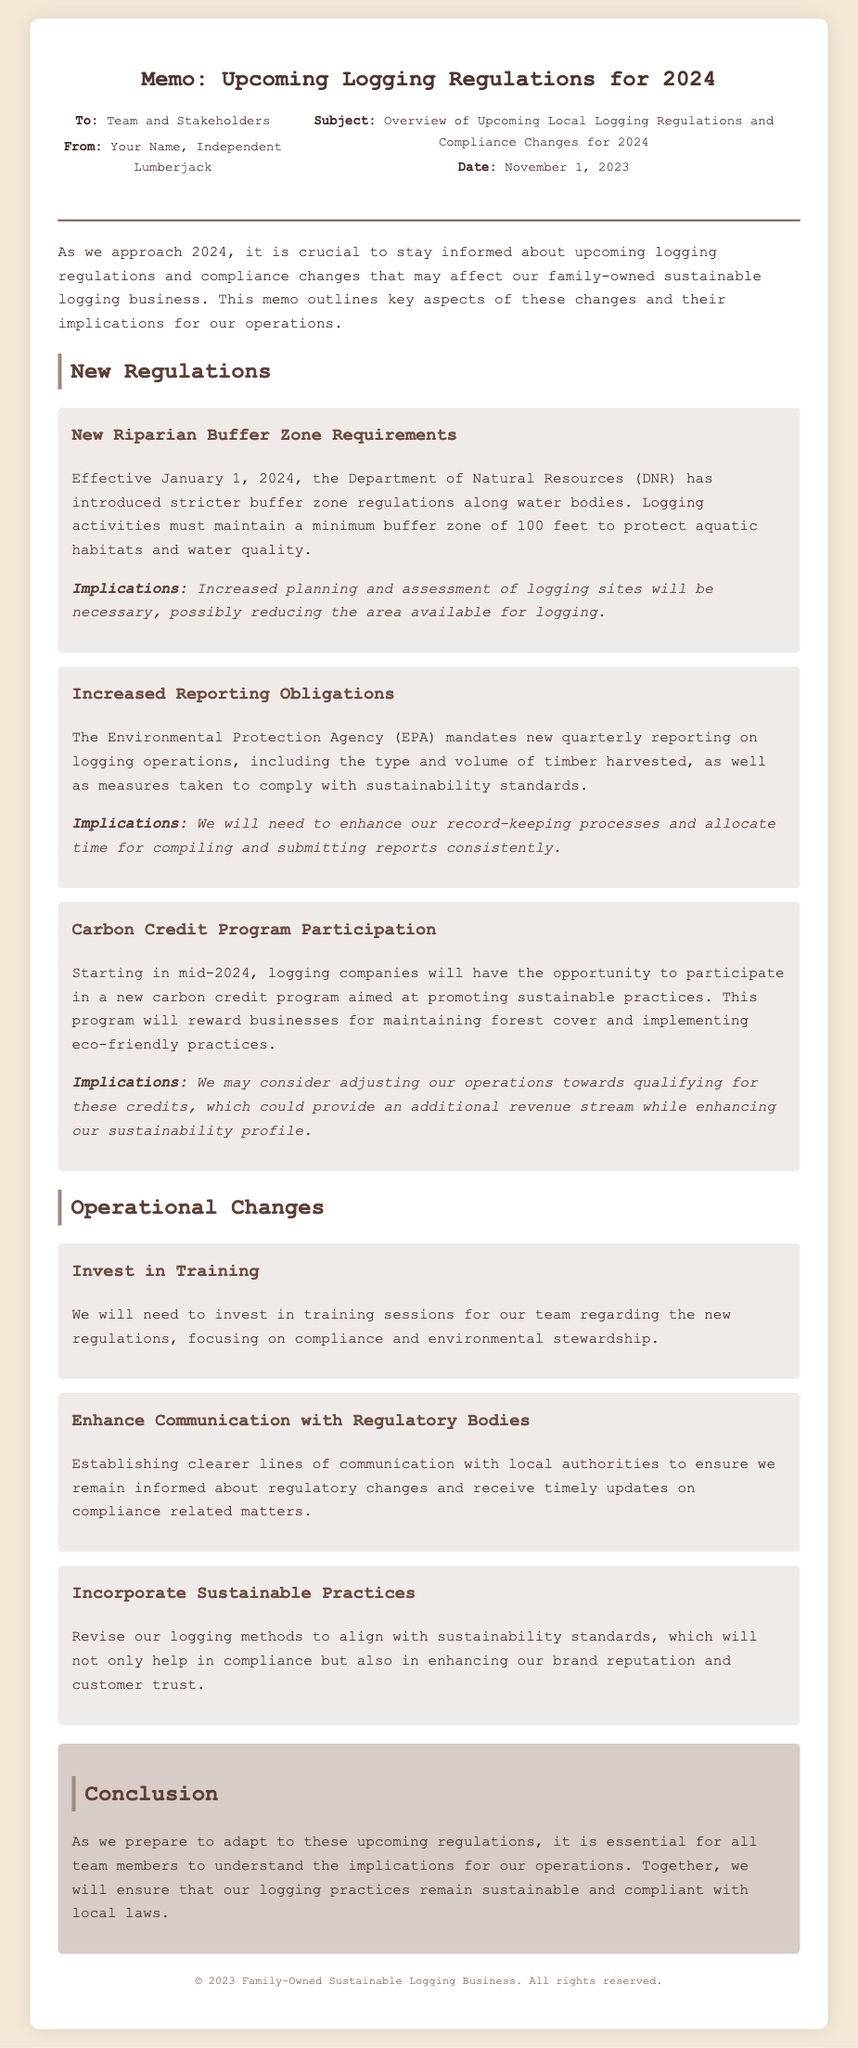What are the new riparian buffer zone requirements? The document states that logging activities must maintain a minimum buffer zone of 100 feet to protect aquatic habitats and water quality.
Answer: 100 feet When do the new regulations take effect? The effective date for the new regulations is highlighted in the document, stating they begin on January 1, 2024.
Answer: January 1, 2024 What agency mandates the increased reporting obligations? The document mentions that the Environmental Protection Agency (EPA) mandates the new reporting obligations.
Answer: Environmental Protection Agency (EPA) What is one implication of the new buffer zone requirements? The document implies that increased planning and assessment of logging sites will be necessary, possibly reducing the area available for logging.
Answer: Reduced area available for logging What will the carbon credit program reward businesses for? The document states that the carbon credit program will reward businesses for maintaining forest cover and implementing eco-friendly practices.
Answer: Maintaining forest cover What operational change involves improving communication? The document suggests enhancing communication with local authorities to ensure timely updates on compliance related matters.
Answer: Enhance Communication with Regulatory Bodies How many operational changes are mentioned in the document? The document lists three operational changes that need to occur within the business.
Answer: Three What is the conclusion of the memo regarding the impact of the regulations? The conclusion emphasizes that adapting to the upcoming regulations is essential for sustainable and compliant logging practices.
Answer: Sustainable and compliant logging practices 